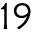<formula> <loc_0><loc_0><loc_500><loc_500>1 9</formula> 